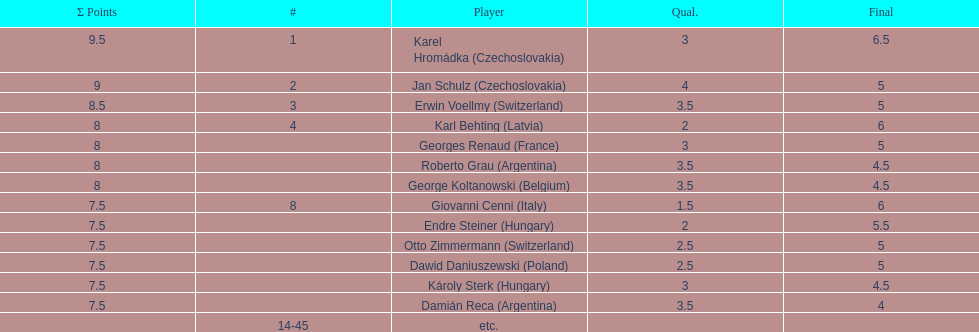How many players obtained final scores above 5? 4. 